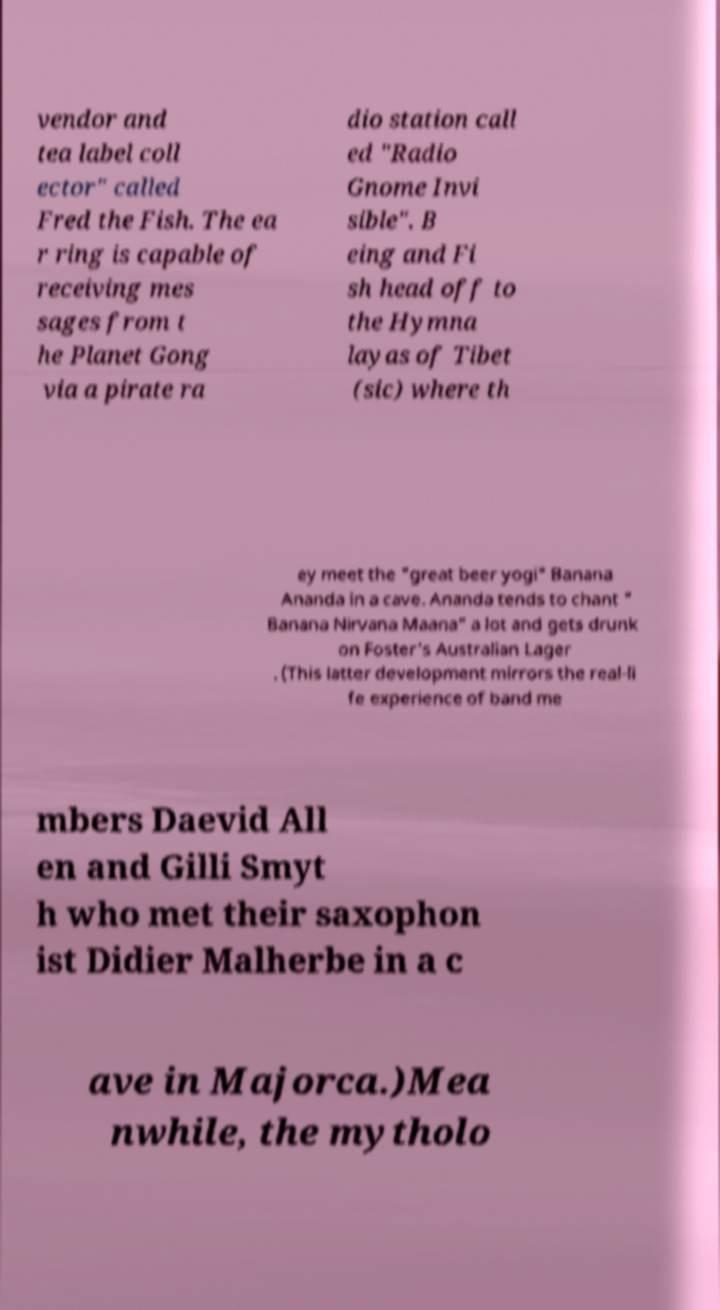Can you accurately transcribe the text from the provided image for me? vendor and tea label coll ector" called Fred the Fish. The ea r ring is capable of receiving mes sages from t he Planet Gong via a pirate ra dio station call ed "Radio Gnome Invi sible". B eing and Fi sh head off to the Hymna layas of Tibet (sic) where th ey meet the "great beer yogi" Banana Ananda in a cave. Ananda tends to chant " Banana Nirvana Maana" a lot and gets drunk on Foster's Australian Lager . (This latter development mirrors the real-li fe experience of band me mbers Daevid All en and Gilli Smyt h who met their saxophon ist Didier Malherbe in a c ave in Majorca.)Mea nwhile, the mytholo 